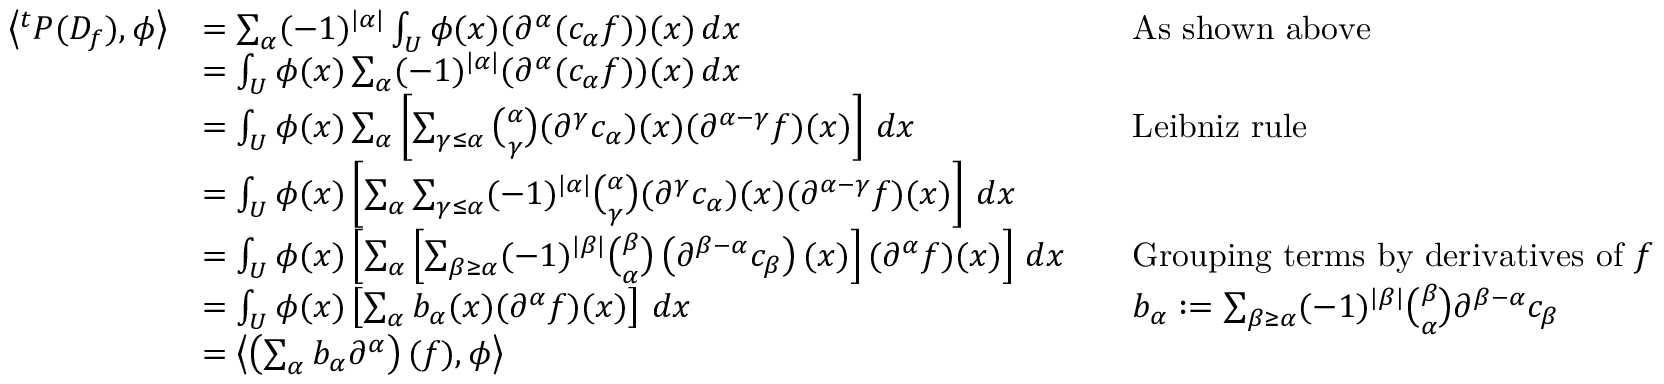Convert formula to latex. <formula><loc_0><loc_0><loc_500><loc_500>{ \begin{array} { r l r l } { \left \langle ^ { t } P ( D _ { f } ) , \phi \right \rangle } & { = \sum _ { \alpha } ( - 1 ) ^ { | \alpha | } \int _ { U } \phi ( x ) ( \partial ^ { \alpha } ( c _ { \alpha } f ) ) ( x ) \, d x } & & { A s s h o w n a b o v e } \\ & { = \int _ { U } \phi ( x ) \sum _ { \alpha } ( - 1 ) ^ { | \alpha | } ( \partial ^ { \alpha } ( c _ { \alpha } f ) ) ( x ) \, d x } \\ & { = \int _ { U } \phi ( x ) \sum _ { \alpha } \left [ \sum _ { \gamma \leq \alpha } { \binom { \alpha } { \gamma } } ( \partial ^ { \gamma } c _ { \alpha } ) ( x ) ( \partial ^ { \alpha - \gamma } f ) ( x ) \right ] \, d x } & & { L e i b n i z r u l e } \\ & { = \int _ { U } \phi ( x ) \left [ \sum _ { \alpha } \sum _ { \gamma \leq \alpha } ( - 1 ) ^ { | \alpha | } { \binom { \alpha } { \gamma } } ( \partial ^ { \gamma } c _ { \alpha } ) ( x ) ( \partial ^ { \alpha - \gamma } f ) ( x ) \right ] \, d x } \\ & { = \int _ { U } \phi ( x ) \left [ \sum _ { \alpha } \left [ \sum _ { \beta \geq \alpha } ( - 1 ) ^ { | \beta | } { \binom { \beta } { \alpha } } \left ( \partial ^ { \beta - \alpha } c _ { \beta } \right ) ( x ) \right ] ( \partial ^ { \alpha } f ) ( x ) \right ] \, d x } & & { { G r o u p i n g t e r m s b y d e r i v a t i v e s o f } f } \\ & { = \int _ { U } \phi ( x ) \left [ \sum _ { \alpha } b _ { \alpha } ( x ) ( \partial ^ { \alpha } f ) ( x ) \right ] \, d x } & & { b _ { \alpha } \colon = \sum _ { \beta \geq \alpha } ( - 1 ) ^ { | \beta | } { \binom { \beta } { \alpha } } \partial ^ { \beta - \alpha } c _ { \beta } } \\ & { = \left \langle \left ( \sum _ { \alpha } b _ { \alpha } \partial ^ { \alpha } \right ) ( f ) , \phi \right \rangle } \end{array} }</formula> 